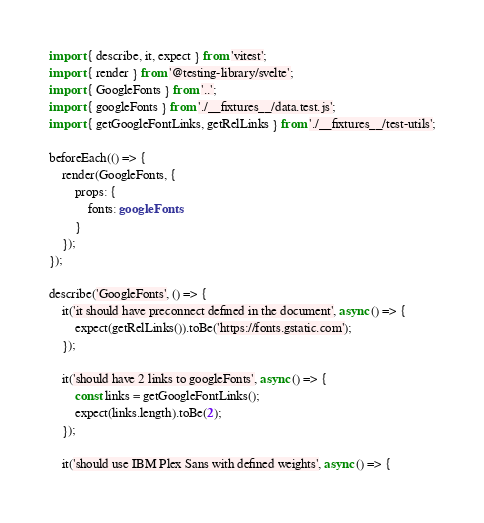Convert code to text. <code><loc_0><loc_0><loc_500><loc_500><_TypeScript_>import { describe, it, expect } from 'vitest';
import { render } from '@testing-library/svelte';
import { GoogleFonts } from '..';
import { googleFonts } from './__fixtures__/data.test.js';
import { getGoogleFontLinks, getRelLinks } from './__fixtures__/test-utils';

beforeEach(() => {
	render(GoogleFonts, {
		props: {
			fonts: googleFonts
		}
	});
});

describe('GoogleFonts', () => {
	it('it should have preconnect defined in the document', async () => {
		expect(getRelLinks()).toBe('https://fonts.gstatic.com');
	});

	it('should have 2 links to googleFonts', async () => {
		const links = getGoogleFontLinks();
		expect(links.length).toBe(2);
	});

	it('should use IBM Plex Sans with defined weights', async () => {</code> 